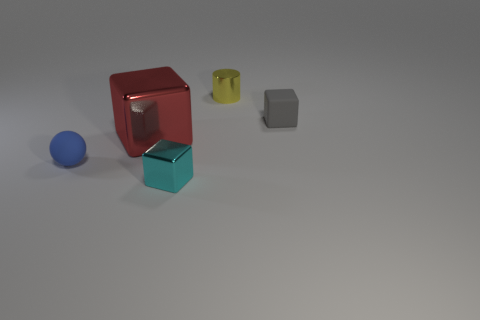Subtract all large red shiny cubes. How many cubes are left? 2 Subtract all red blocks. How many blocks are left? 2 Subtract all blocks. How many objects are left? 2 Add 1 small cyan cylinders. How many objects exist? 6 Subtract 1 spheres. How many spheres are left? 0 Subtract all brown blocks. Subtract all purple cylinders. How many blocks are left? 3 Subtract all red balls. How many red cubes are left? 1 Subtract all cyan metallic spheres. Subtract all metallic objects. How many objects are left? 2 Add 1 small yellow cylinders. How many small yellow cylinders are left? 2 Add 1 yellow blocks. How many yellow blocks exist? 1 